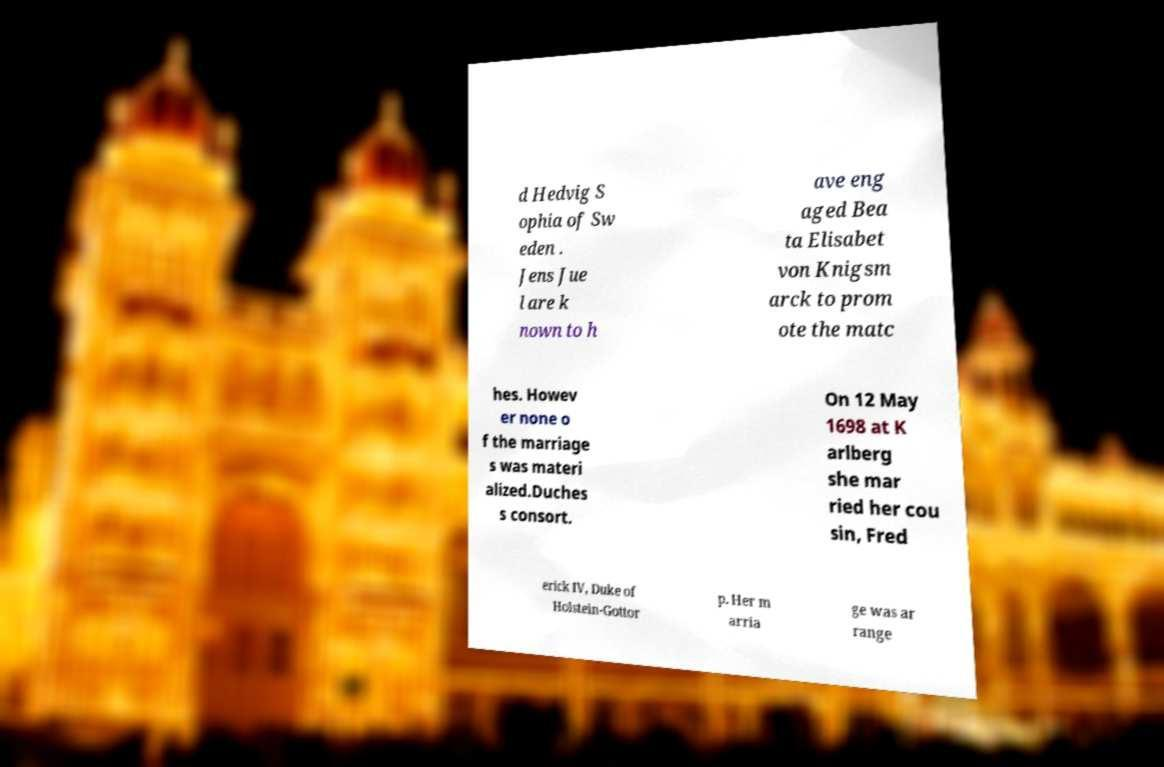I need the written content from this picture converted into text. Can you do that? d Hedvig S ophia of Sw eden . Jens Jue l are k nown to h ave eng aged Bea ta Elisabet von Knigsm arck to prom ote the matc hes. Howev er none o f the marriage s was materi alized.Duches s consort. On 12 May 1698 at K arlberg she mar ried her cou sin, Fred erick IV, Duke of Holstein-Gottor p. Her m arria ge was ar range 